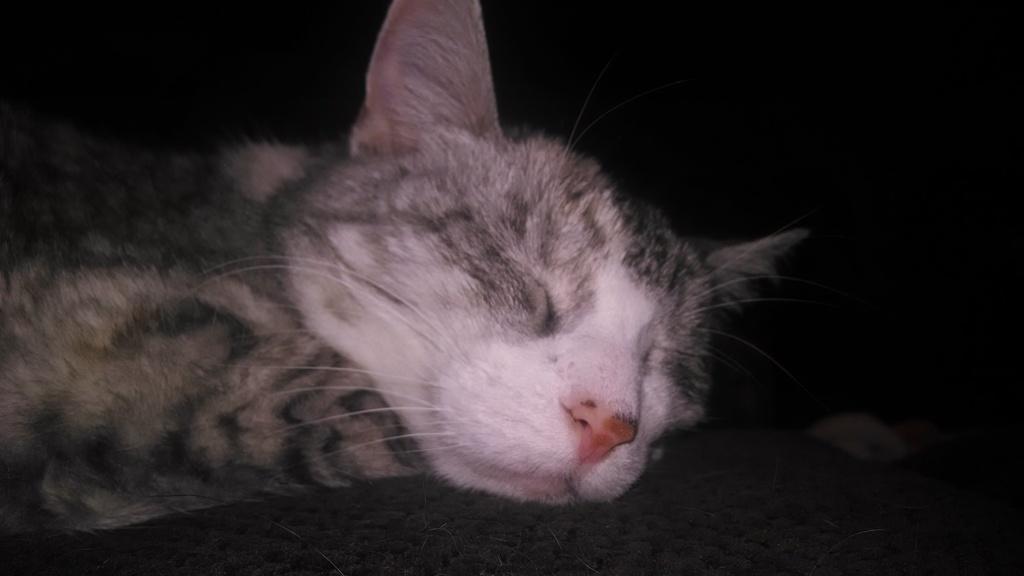Please provide a concise description of this image. This picture contains a black cat which is sleeping. In the background, it is black in color and this picture is clicked in the dark. 